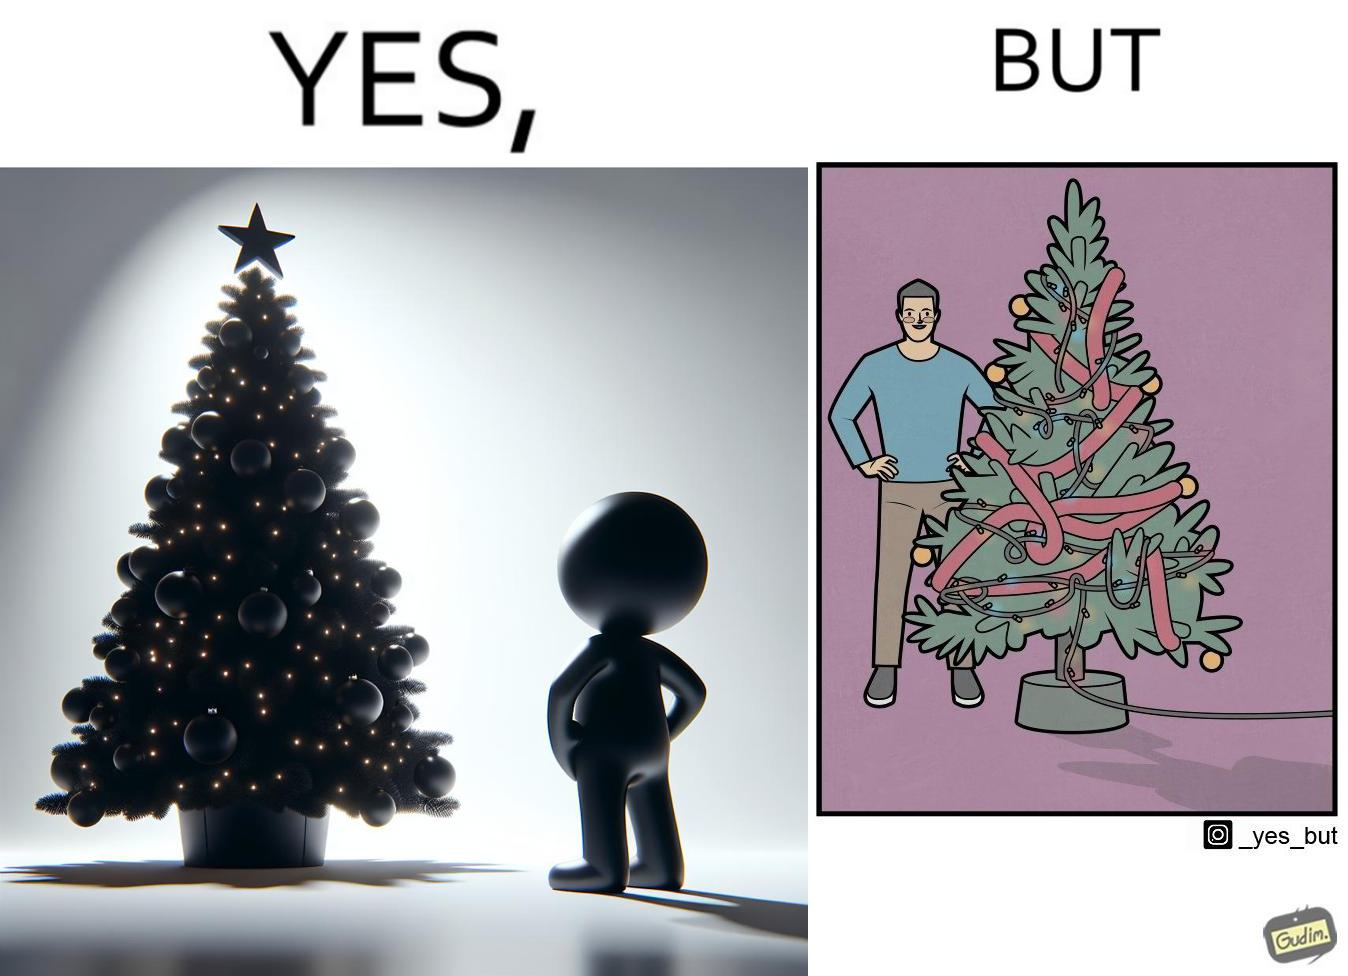Compare the left and right sides of this image. In the left part of the image: a person looking at a X-mas tree In the right part of the image: a person looking at a X-mas tree on which various bulbs are put and are connected to electricity source 